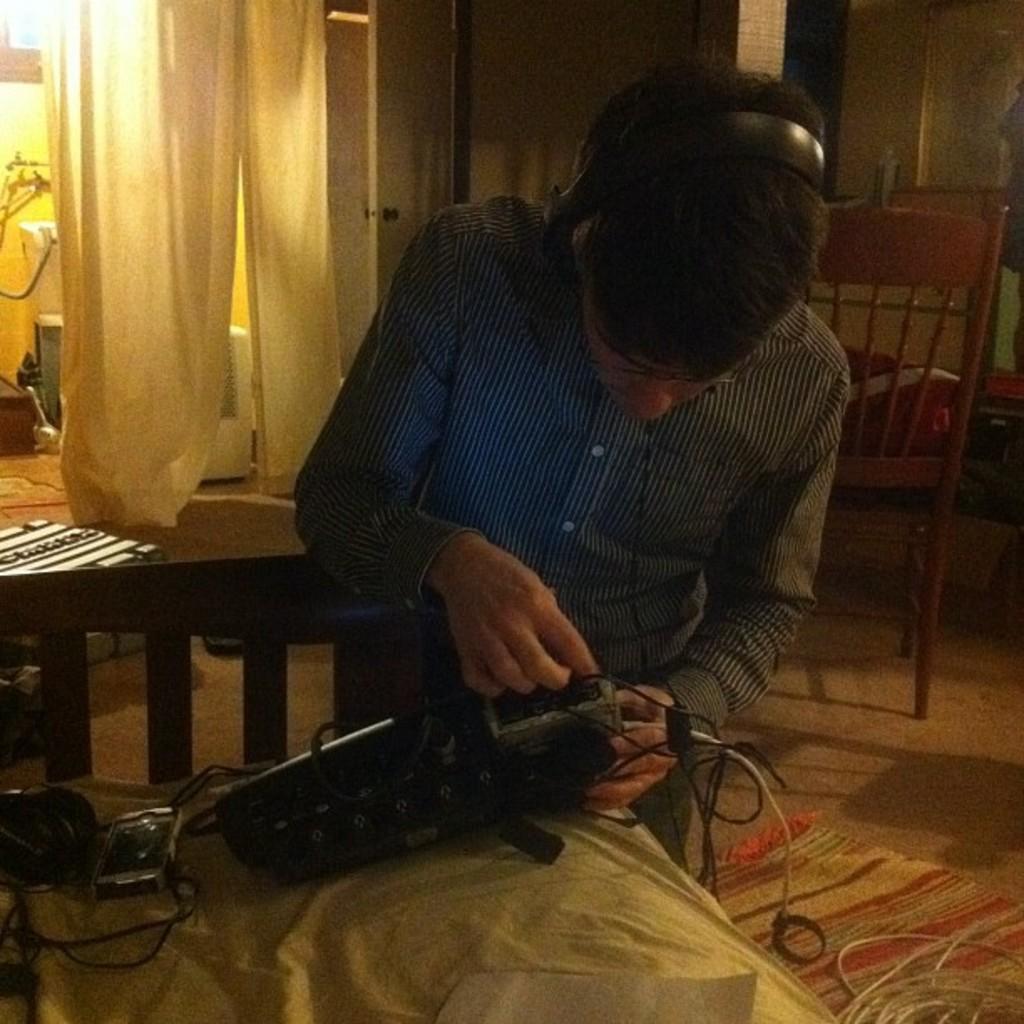Please provide a concise description of this image. This picture shows a man standing and connecting a wire to a machine and we see a chair and curtains hanging. 